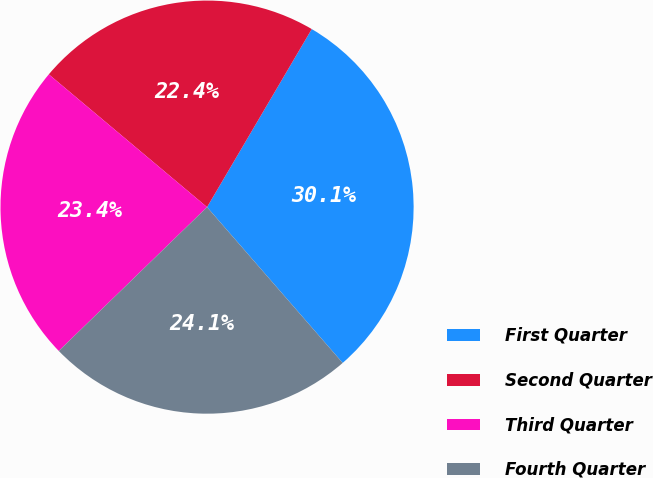<chart> <loc_0><loc_0><loc_500><loc_500><pie_chart><fcel>First Quarter<fcel>Second Quarter<fcel>Third Quarter<fcel>Fourth Quarter<nl><fcel>30.14%<fcel>22.35%<fcel>23.37%<fcel>24.14%<nl></chart> 